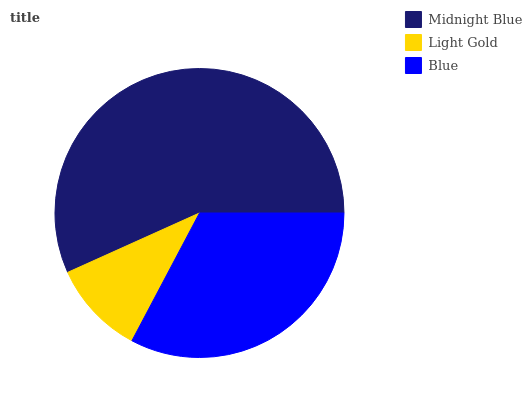Is Light Gold the minimum?
Answer yes or no. Yes. Is Midnight Blue the maximum?
Answer yes or no. Yes. Is Blue the minimum?
Answer yes or no. No. Is Blue the maximum?
Answer yes or no. No. Is Blue greater than Light Gold?
Answer yes or no. Yes. Is Light Gold less than Blue?
Answer yes or no. Yes. Is Light Gold greater than Blue?
Answer yes or no. No. Is Blue less than Light Gold?
Answer yes or no. No. Is Blue the high median?
Answer yes or no. Yes. Is Blue the low median?
Answer yes or no. Yes. Is Midnight Blue the high median?
Answer yes or no. No. Is Light Gold the low median?
Answer yes or no. No. 